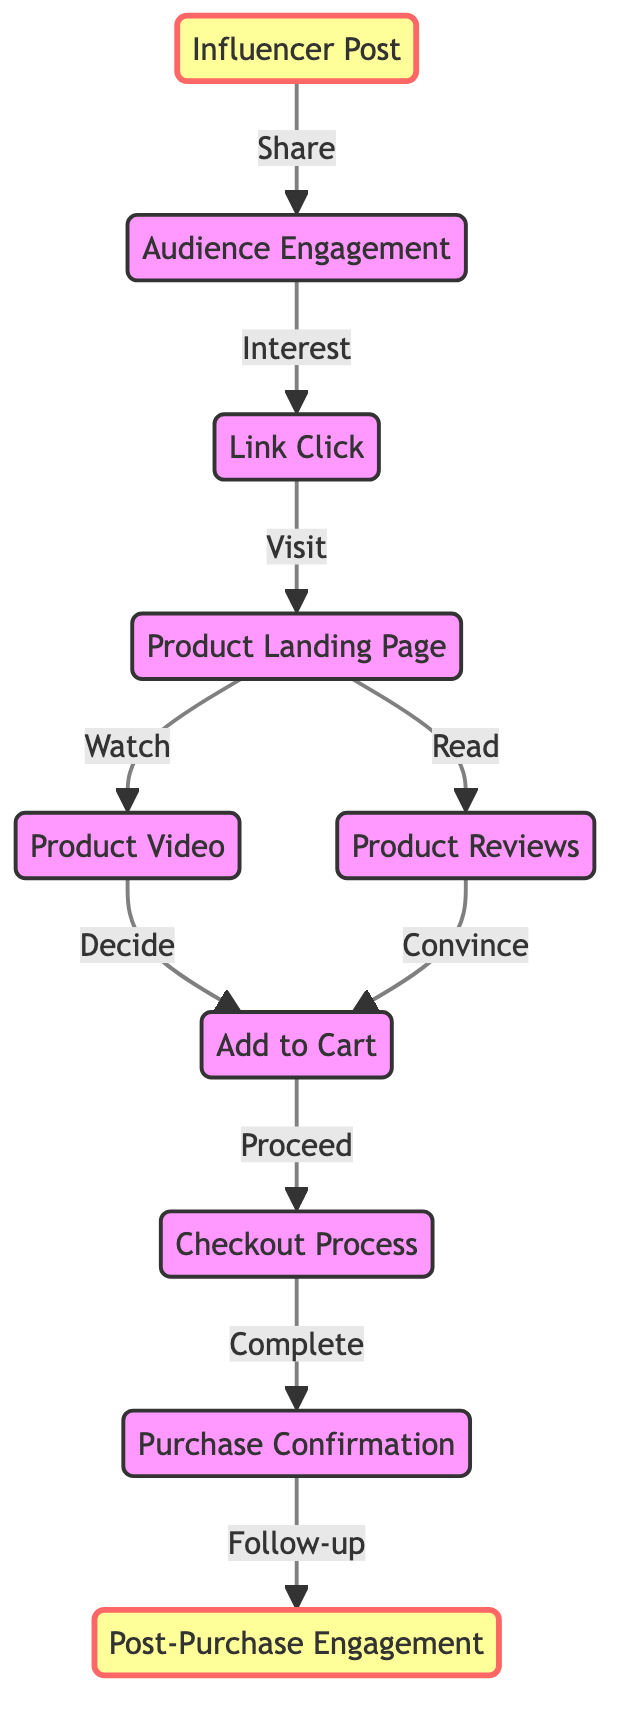What node follows "Add to Cart"? The diagram shows a directed connection from "Add to Cart" to "Checkout Process", indicating that after adding a product to the cart, the next action is to proceed to checkout.
Answer: Checkout Process How many nodes are in the diagram? By counting each unique node listed in the data, we find that there are ten nodes total representing different steps in the customer journey from influencer promotion to purchase.
Answer: 10 What is the relationship between "Link Click" and "Product Landing Page"? The directed edge from "Link Click" to "Product Landing Page" indicates that after clicking the link, the audience is directed to the product landing page as the next step in the journey.
Answer: Visit What follows "Product Landing Page"? The diagram illustrates two branches from "Product Landing Page" leading to "Product Video" and "Product Reviews", meaning the audience can either watch a video or read reviews next.
Answer: Product Video, Product Reviews Which node comes after "Purchase Confirmation"? The flow shows that after "Purchase Confirmation", the next node is "Post-Purchase Engagement", representing the follow-up actions initiated by the tech company.
Answer: Post-Purchase Engagement What is the first step in the customer journey? The starting point of the diagram is "Influencer Post", indicating this is the initial action in the journey where the influencer promotes the product.
Answer: Influencer Post How many directed edges are there in the diagram? By counting all the edges listed in the data, we find there are nine directed edges that represent the flow between the nodes in the customer journey.
Answer: 9 What actions can the audience take after reaching "Product Landing Page"? The diagram indicates two possible actions after reaching the "Product Landing Page": they can watch a "Product Video" or read "Product Reviews".
Answer: Watch Product Video, Read Product Reviews What is the final node in the journey? The last node in the flow shown in the diagram is "Post-Purchase Engagement", which represents the customer experience after completing the purchase.
Answer: Post-Purchase Engagement 